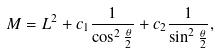Convert formula to latex. <formula><loc_0><loc_0><loc_500><loc_500>M = L ^ { 2 } + c _ { 1 } \frac { 1 } { \cos ^ { 2 } \frac { \theta } { 2 } } + c _ { 2 } \frac { 1 } { \sin ^ { 2 } \frac { \theta } { 2 } } ,</formula> 